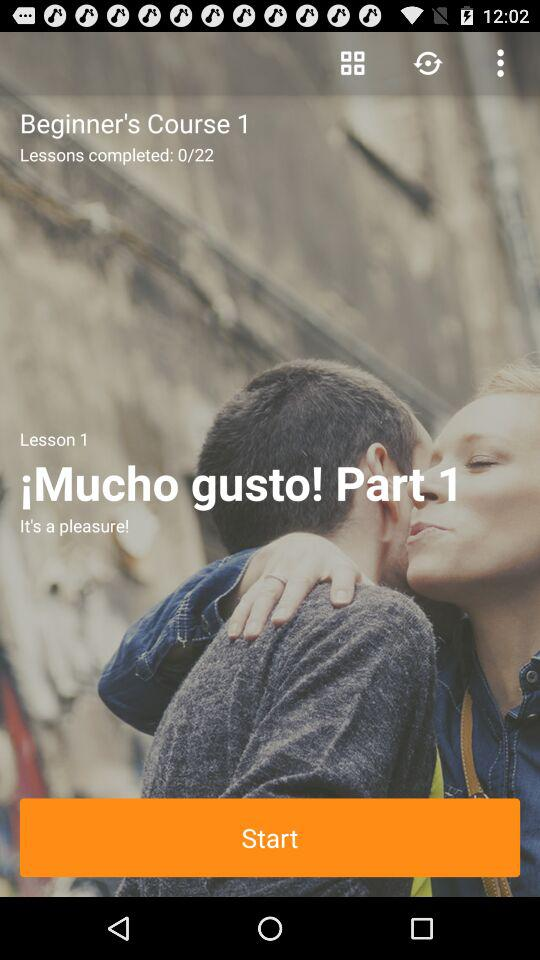What is the name of the lesson? The name of the lesson is "¡Mucho gusto! Part 1". 